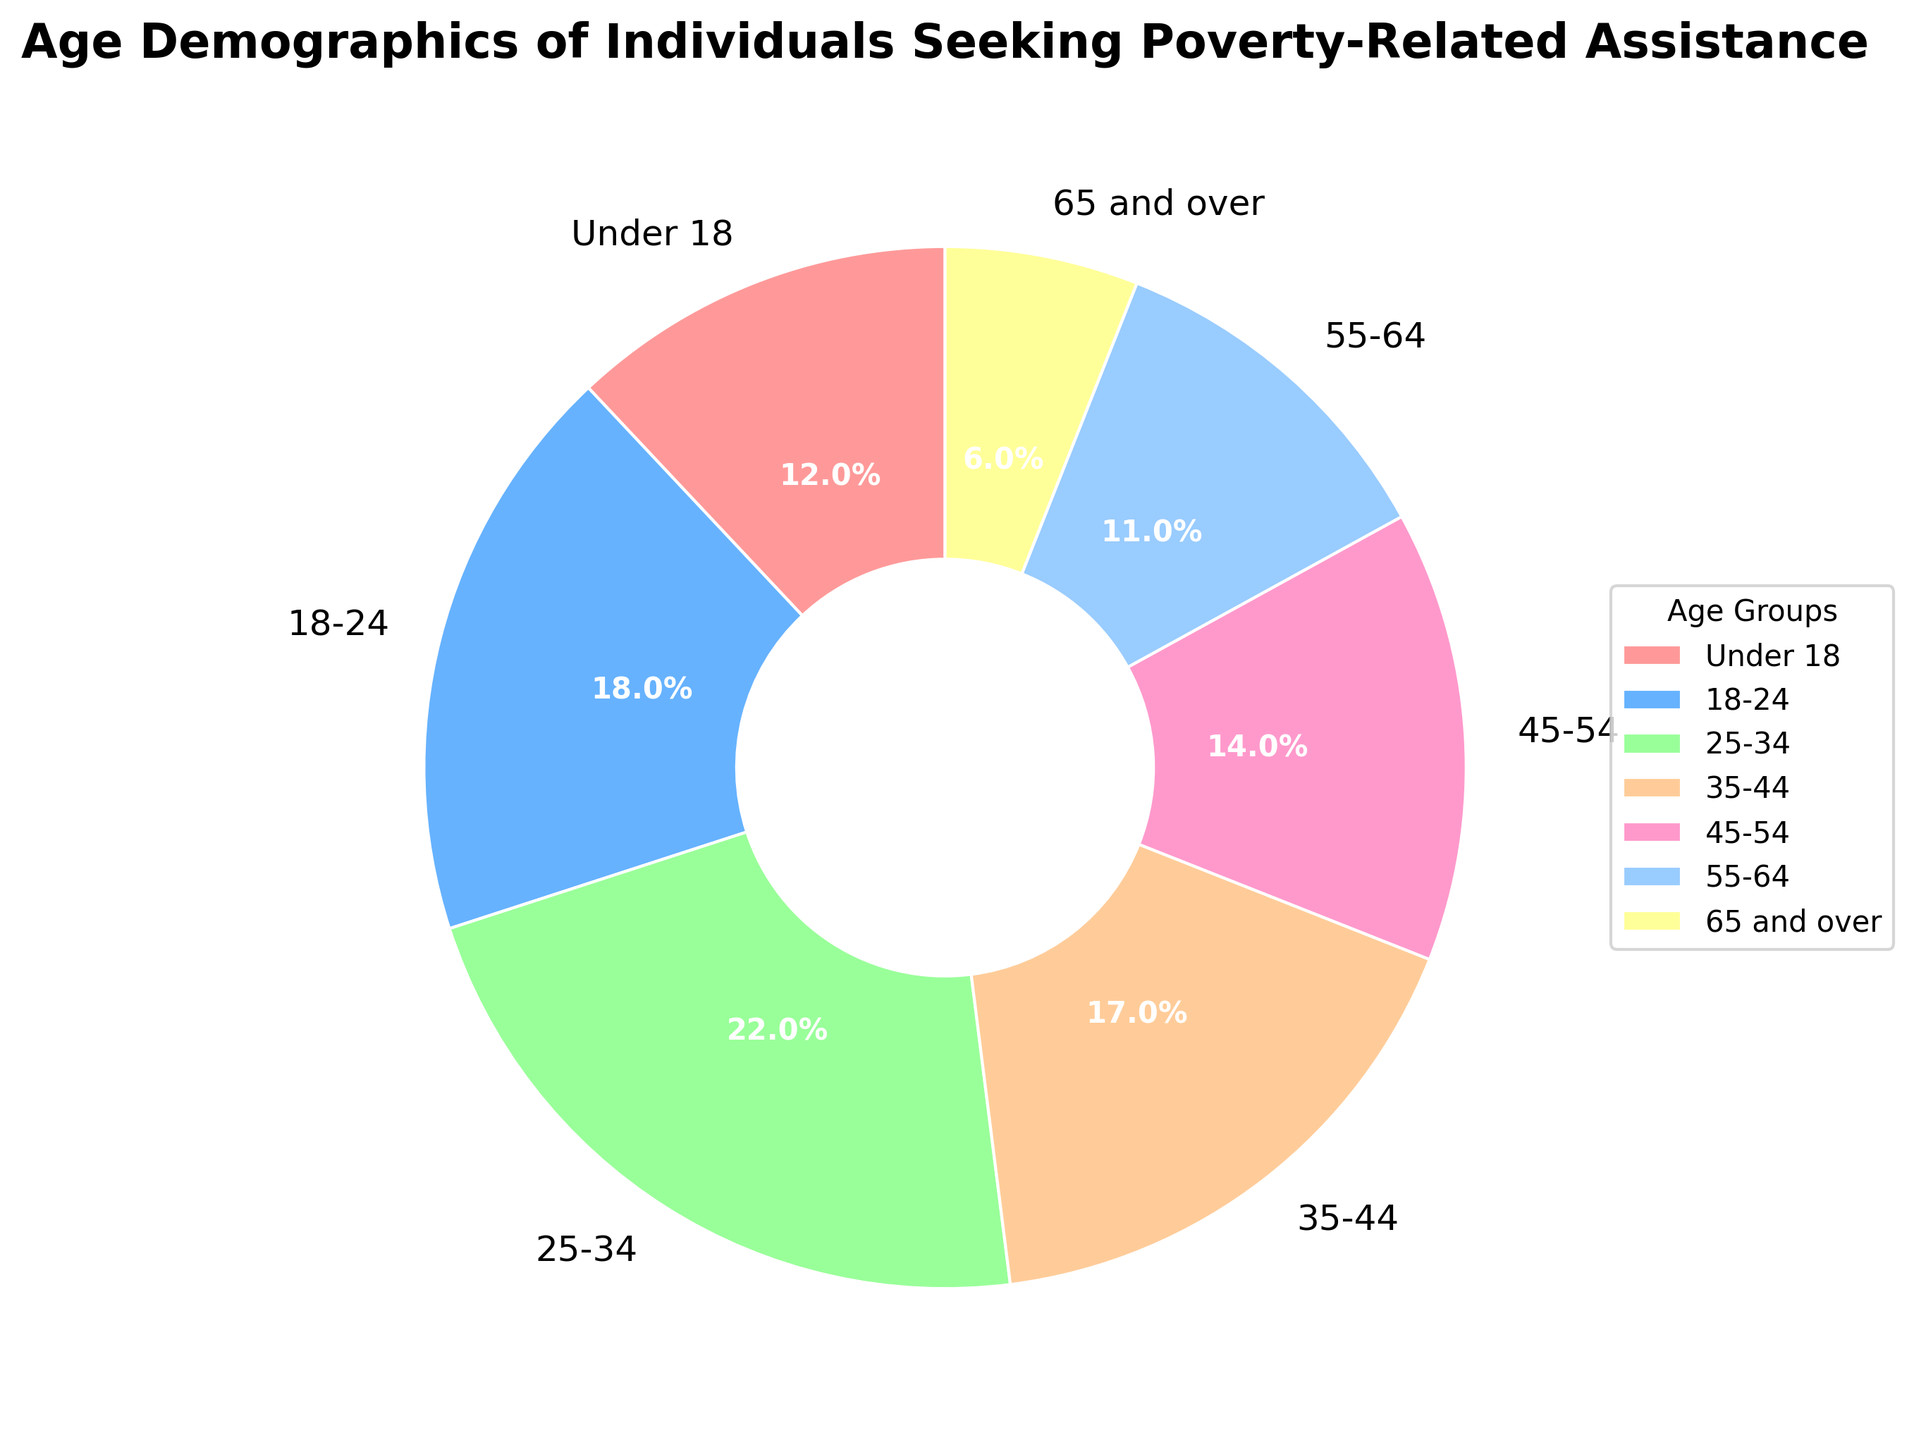What age group has the highest percentage of individuals seeking poverty-related assistance? The largest slice of the pie chart corresponds to the age group 25-34, highlighted by both the segment size and the percentage label.
Answer: 25-34 Which age group represents the smallest segment of the pie chart? The smallest slice of the pie chart is marked as 65 and over, which has the lowest percentage displayed.
Answer: 65 and over What is the combined percentage of individuals under the age of 24 seeking assistance? Sum the percentages of the two groups under 24: 12% (Under 18) + 18% (18-24).
Answer: 30% Compare the percentage of individuals aged 45-54 with those aged 55-64. Which group has a larger percentage? The pie chart shows 14% for the 45-54 age group and 11% for the 55-64 age group. 14% is larger than 11%.
Answer: 45-54 What percentage of individuals seeking assistance are aged between 25 and 44? Sum the percentages for the 25-34 and 35-44 age groups: 22% (25-34) + 17% (35-44).
Answer: 39% Identify the age group(s) with percentages greater than 15%. The pie chart shows the following age groups above 15%: 18-24 (18%), 25-34 (22%), and 35-44 (17%).
Answer: 18-24, 25-34, 35-44 What is the percentage gap between the 25-34 age group and the 65 and over age group? Subtract the percentage of the 65 and over group from the 25-34 group: 22% - 6%.
Answer: 16% Rank the age groups from highest to lowest percentage of individuals seeking assistance. List the age groups based on their percentages in descending order: 25-34 (22%), 18-24 (18%), 35-44 (17%), 45-54 (14%), Under 18 (12%), 55-64 (11%), 65 and over (6%).
Answer: 25-34, 18-24, 35-44, 45-54, Under 18, 55-64, 65 and over What is the total percentage of individuals aged 18 to 54 seeking assistance? Sum the percentages of the age groups 18-24, 25-34, 35-44, and 45-54: 18% + 22% + 17% + 14%.
Answer: 71% How much less is the percentage of individuals aged 55-64 compared to those aged 45-54? Subtract the percentage of the 55-64 group from the 45-54 group: 14% (45-54) - 11% (55-64).
Answer: 3% 